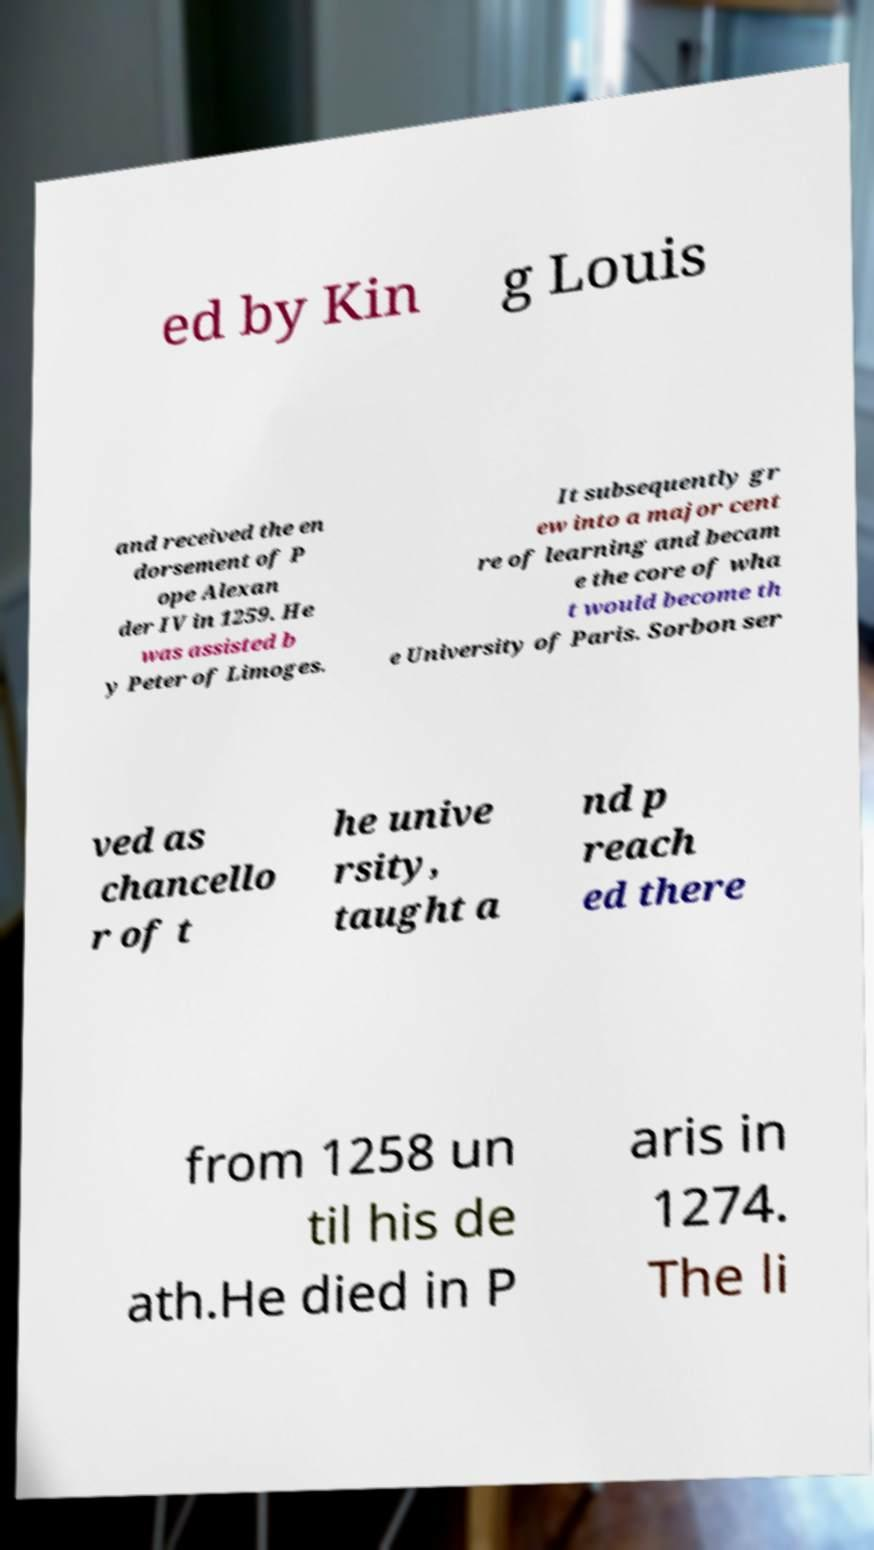There's text embedded in this image that I need extracted. Can you transcribe it verbatim? ed by Kin g Louis and received the en dorsement of P ope Alexan der IV in 1259. He was assisted b y Peter of Limoges. It subsequently gr ew into a major cent re of learning and becam e the core of wha t would become th e University of Paris. Sorbon ser ved as chancello r of t he unive rsity, taught a nd p reach ed there from 1258 un til his de ath.He died in P aris in 1274. The li 